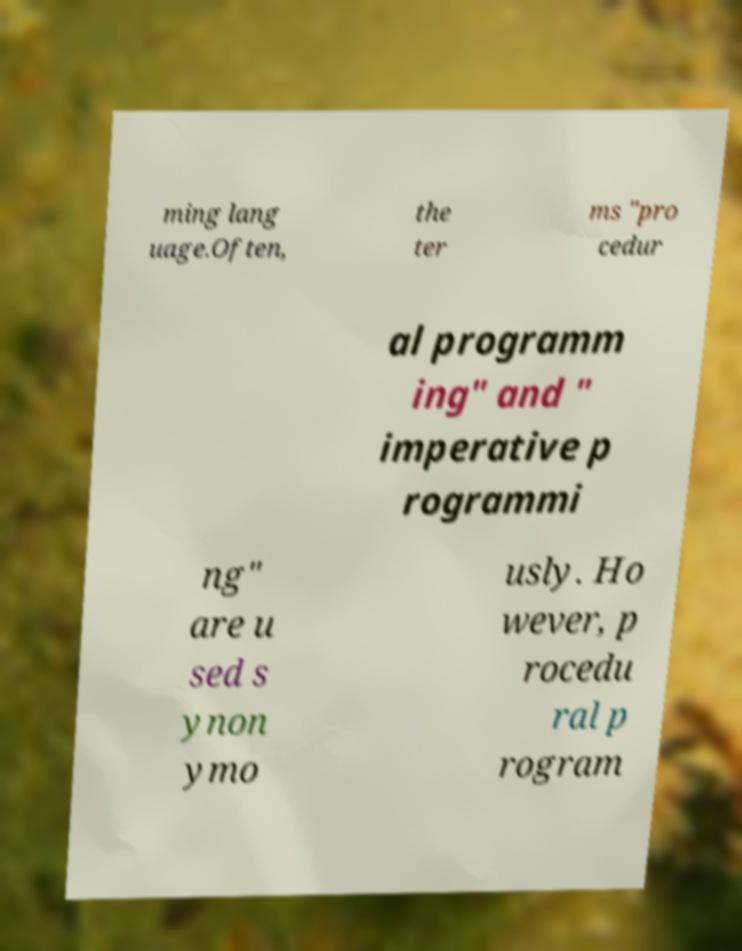Could you assist in decoding the text presented in this image and type it out clearly? ming lang uage.Often, the ter ms "pro cedur al programm ing" and " imperative p rogrammi ng" are u sed s ynon ymo usly. Ho wever, p rocedu ral p rogram 